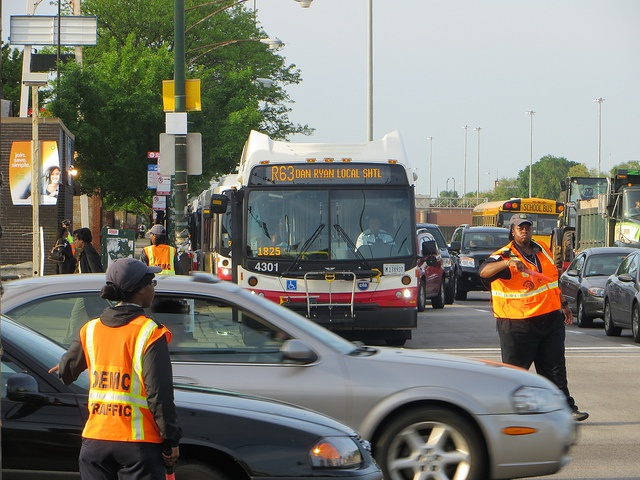Describe the objects in this image and their specific colors. I can see car in black, darkgray, and gray tones, bus in black, gray, darkgray, and blue tones, people in black, orange, gray, and red tones, people in black, red, orange, and maroon tones, and truck in black, gray, and darkgray tones in this image. 